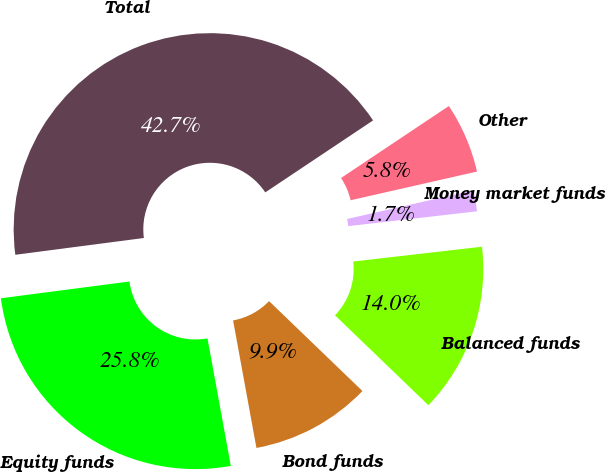Convert chart. <chart><loc_0><loc_0><loc_500><loc_500><pie_chart><fcel>Equity funds<fcel>Bond funds<fcel>Balanced funds<fcel>Money market funds<fcel>Other<fcel>Total<nl><fcel>25.82%<fcel>9.92%<fcel>14.02%<fcel>1.73%<fcel>5.82%<fcel>42.7%<nl></chart> 